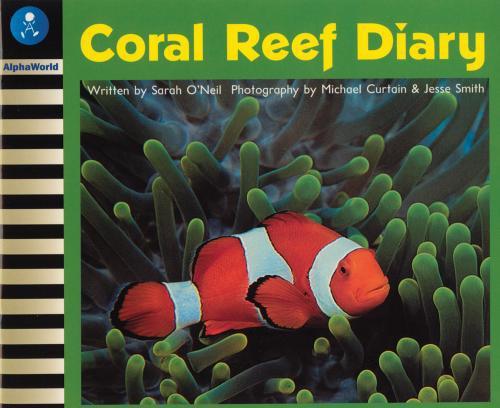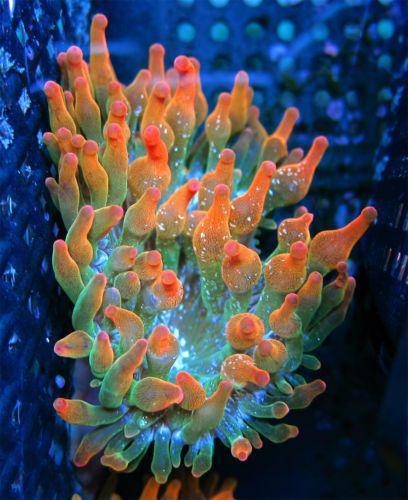The first image is the image on the left, the second image is the image on the right. Considering the images on both sides, is "Each image shows clown fish swimming among anemone tendrils, but the right image contains at least twice as many clown fish." valid? Answer yes or no. No. The first image is the image on the left, the second image is the image on the right. Evaluate the accuracy of this statement regarding the images: "there are two orange and white colored fish swimming near an anemone". Is it true? Answer yes or no. No. 